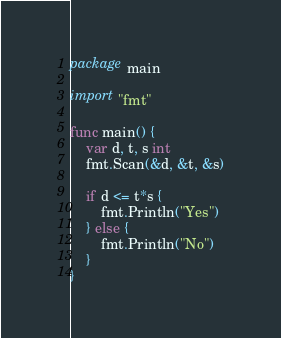Convert code to text. <code><loc_0><loc_0><loc_500><loc_500><_Go_>package main

import "fmt"

func main() {
	var d, t, s int
	fmt.Scan(&d, &t, &s)

	if d <= t*s {
		fmt.Println("Yes")
	} else {
		fmt.Println("No")
	}
}
</code> 